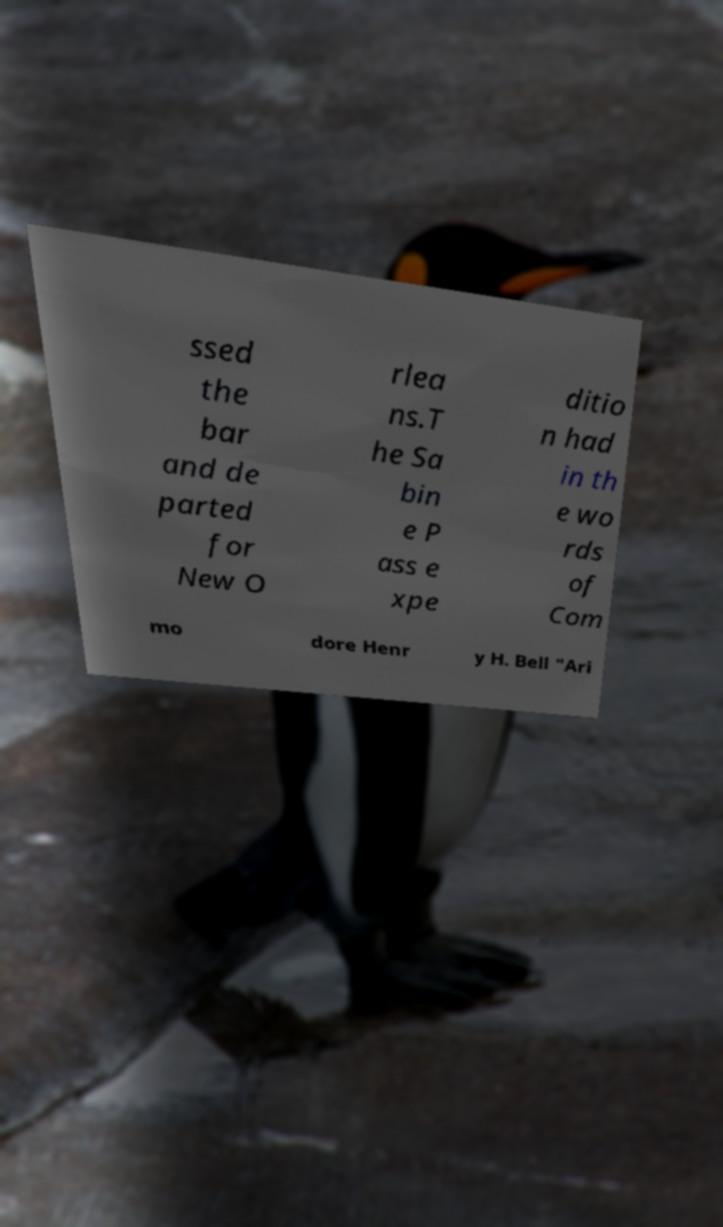Please read and relay the text visible in this image. What does it say? ssed the bar and de parted for New O rlea ns.T he Sa bin e P ass e xpe ditio n had in th e wo rds of Com mo dore Henr y H. Bell "Ari 